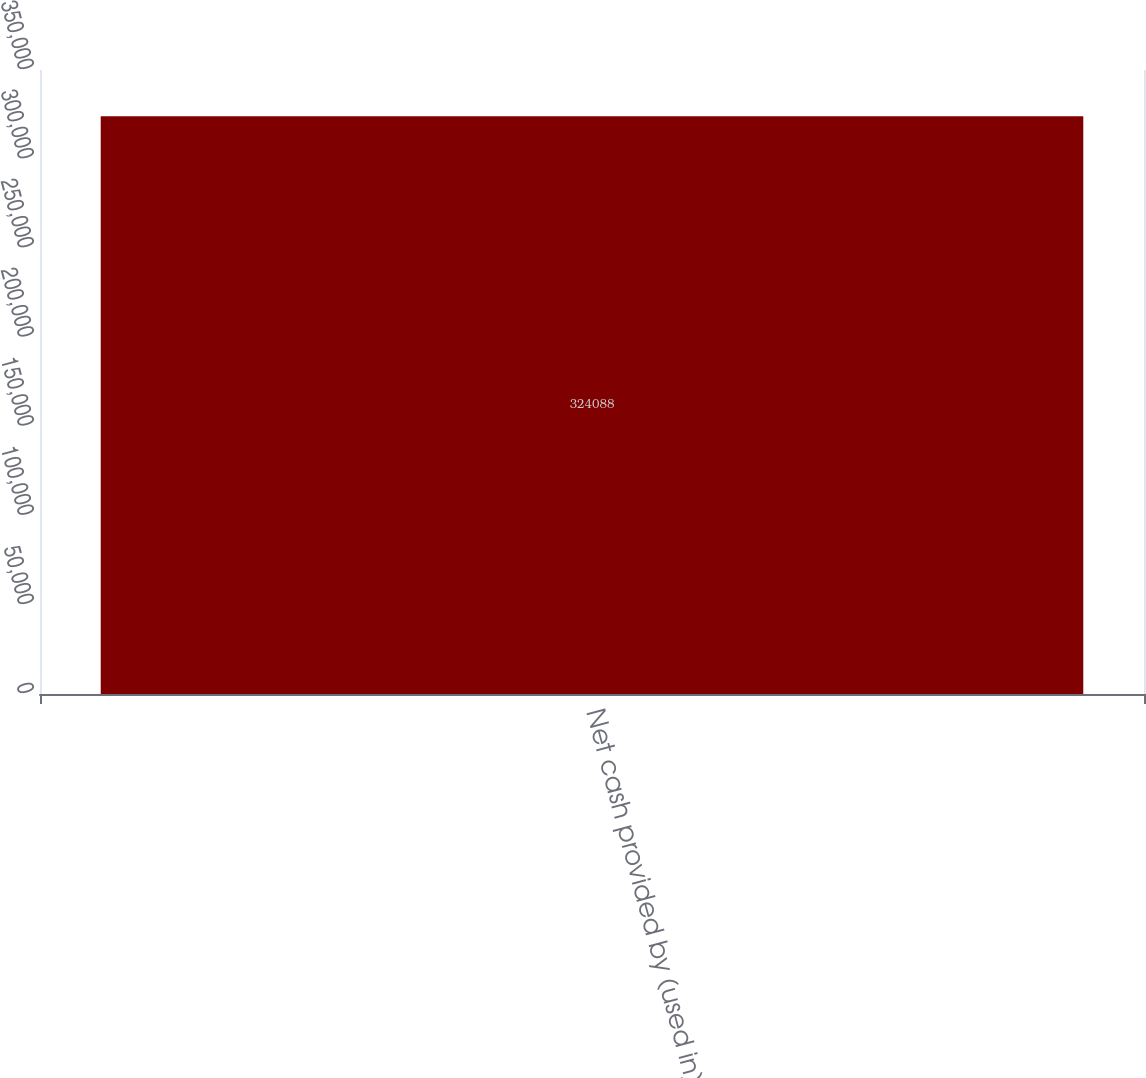<chart> <loc_0><loc_0><loc_500><loc_500><bar_chart><fcel>Net cash provided by (used in)<nl><fcel>324088<nl></chart> 